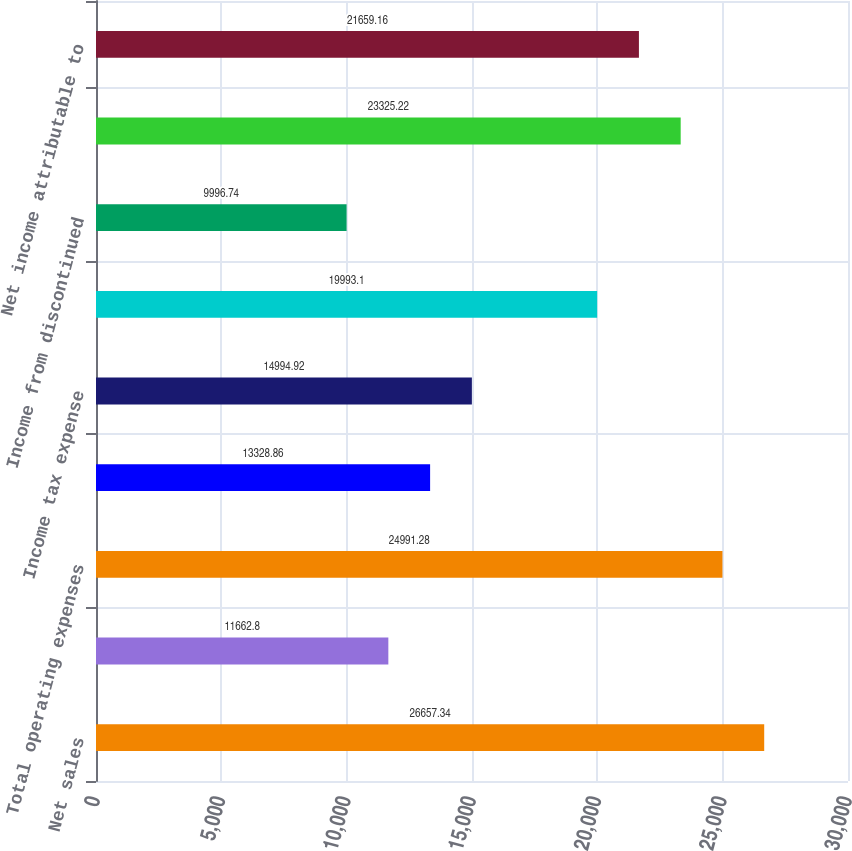<chart> <loc_0><loc_0><loc_500><loc_500><bar_chart><fcel>Net sales<fcel>Amortization<fcel>Total operating expenses<fcel>Interest expense<fcel>Income tax expense<fcel>Income from continuing<fcel>Income from discontinued<fcel>Net income<fcel>Net income attributable to<nl><fcel>26657.3<fcel>11662.8<fcel>24991.3<fcel>13328.9<fcel>14994.9<fcel>19993.1<fcel>9996.74<fcel>23325.2<fcel>21659.2<nl></chart> 